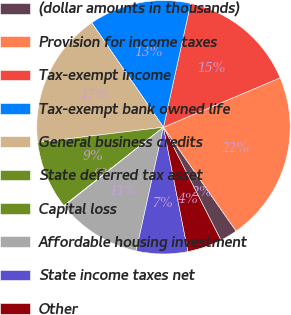Convert chart to OTSL. <chart><loc_0><loc_0><loc_500><loc_500><pie_chart><fcel>(dollar amounts in thousands)<fcel>Provision for income taxes<fcel>Tax-exempt income<fcel>Tax-exempt bank owned life<fcel>General business credits<fcel>State deferred tax asset<fcel>Capital loss<fcel>Affordable housing investment<fcel>State income taxes net<fcel>Other<nl><fcel>2.23%<fcel>21.66%<fcel>15.18%<fcel>13.02%<fcel>17.34%<fcel>8.7%<fcel>0.07%<fcel>10.86%<fcel>6.55%<fcel>4.39%<nl></chart> 